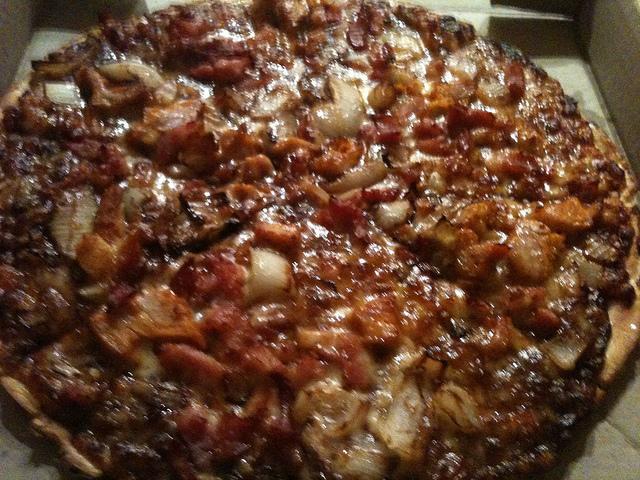Does the pizza have onions?
Write a very short answer. Yes. Would a vegetarian eat this pizza?
Quick response, please. No. Is the pizza burnt?
Short answer required. Yes. 